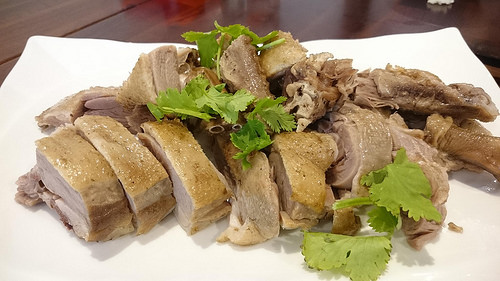<image>
Is the meat on the table? Yes. Looking at the image, I can see the meat is positioned on top of the table, with the table providing support. Where is the meat in relation to the herb? Is it in front of the herb? No. The meat is not in front of the herb. The spatial positioning shows a different relationship between these objects. 